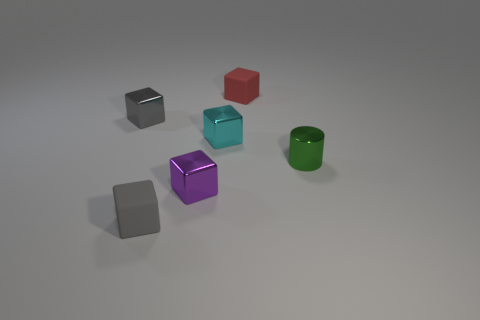Subtract all gray shiny cubes. How many cubes are left? 4 Subtract all red cubes. How many cubes are left? 4 Subtract 1 cubes. How many cubes are left? 4 Subtract all yellow cubes. How many red cylinders are left? 0 Subtract all cubes. How many objects are left? 1 Subtract all cyan blocks. Subtract all yellow cylinders. How many blocks are left? 4 Subtract all big yellow rubber blocks. Subtract all gray blocks. How many objects are left? 4 Add 4 green things. How many green things are left? 5 Add 4 small rubber cylinders. How many small rubber cylinders exist? 4 Add 1 metallic cylinders. How many objects exist? 7 